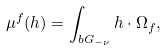Convert formula to latex. <formula><loc_0><loc_0><loc_500><loc_500>\mu ^ { f } ( h ) = \int _ { b G _ { - \nu } } h \cdot \Omega _ { f } ,</formula> 